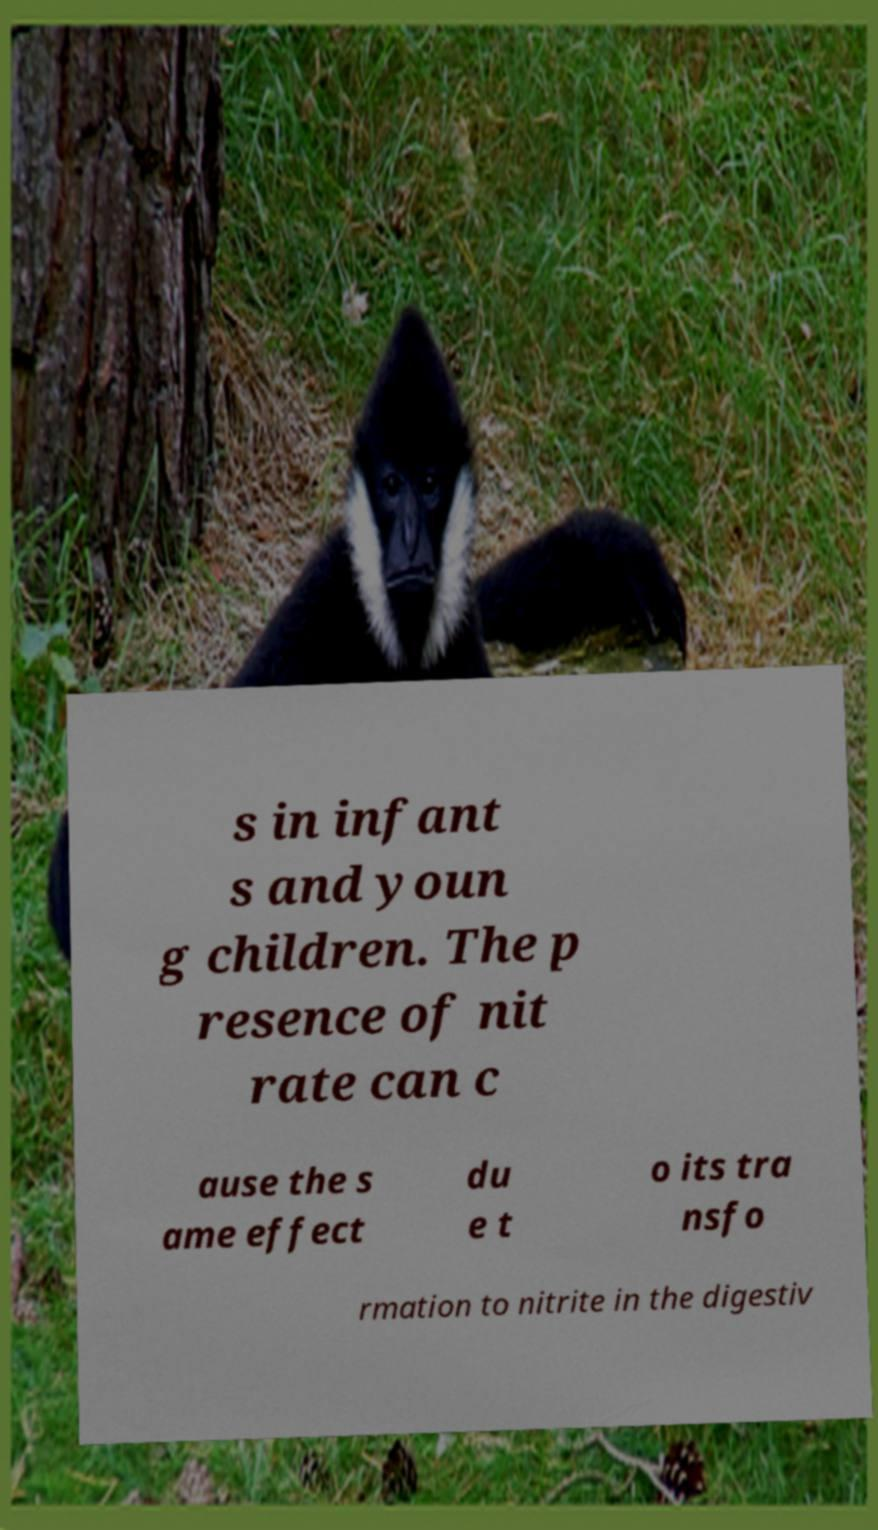Please identify and transcribe the text found in this image. s in infant s and youn g children. The p resence of nit rate can c ause the s ame effect du e t o its tra nsfo rmation to nitrite in the digestiv 